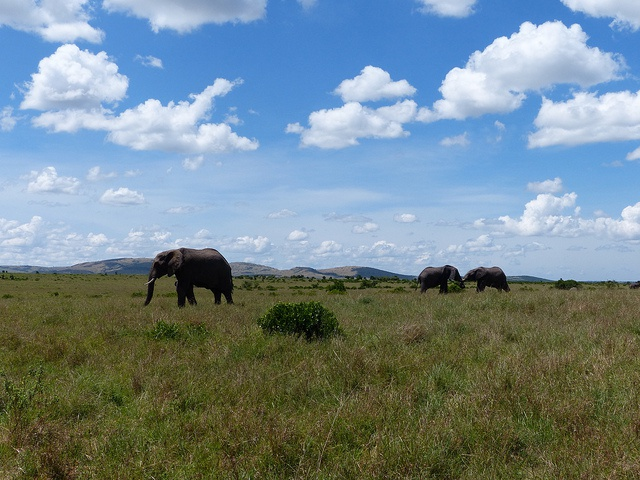Describe the objects in this image and their specific colors. I can see elephant in darkgray, black, gray, and darkgreen tones, elephant in darkgray, black, and gray tones, and elephant in darkgray, black, gray, and darkgreen tones in this image. 